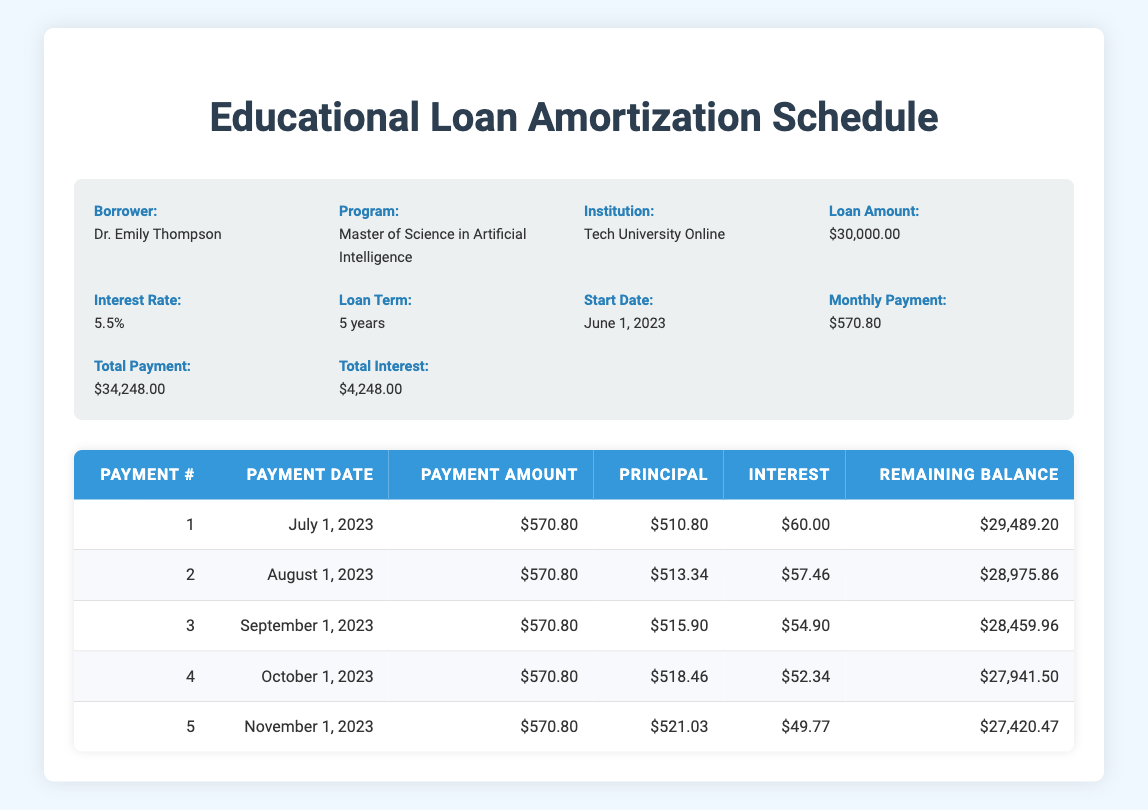What is the loan amount taken by Dr. Emily Thompson? The loan details section states that the loan amount is 30,000.00, which can be directly found in the table under "Loan Amount."
Answer: 30,000.00 What is the interest rate for this loan? The interest rate is listed in the loan details section, which indicates it is 5.5, directly found in the "Interest Rate" part of the table.
Answer: 5.5 How much of the first payment goes to principal? The first payment's breakdown in the payment schedule shows that 510.80 is allocated to principal for payment number 1. This is directly mentioned in the "Principal" column.
Answer: 510.80 What is the total interest paid after the first five payments? The total interest paid over the first five payments can be calculated by summing up the "Interest" column for the first five rows: 60.00 + 57.46 + 54.90 + 52.34 + 49.77 = 274.47.
Answer: 274.47 Is the monthly payment consistent throughout the payment schedule? Observing the payment schedule, each listed monthly payment is the same at 570.80, confirming that it remains consistent.
Answer: Yes What will be the remaining balance after the fourth payment? To find the remaining balance after the fourth payment, we can look at the table's "Remaining Balance" column for payment number 4, which shows a value of 27,941.50.
Answer: 27,941.50 How much total payment will Dr. Emily Thompson make by the end of the loan term? The total payment amount is provided directly in the loan details section, which indicates it sums up to 34,248.00, reflecting the total payment by the end of the loan term.
Answer: 34,248.00 What is the average monthly principal reduction over the first five payments? To find the average monthly principal reduction, we add the principal amounts from the first five payments: 510.80 + 513.34 + 515.90 + 518.46 + 521.03 = 2579.53. Then, we divide by the number of payments, which is 5: 2579.53 / 5 = 515.91.
Answer: 515.91 How much total principal has been paid off after the third payment? We add the principal amounts from the first three payments: 510.80 + 513.34 + 515.90 = 1540.04. This gives the total principal paid off after the third payment.
Answer: 1540.04 